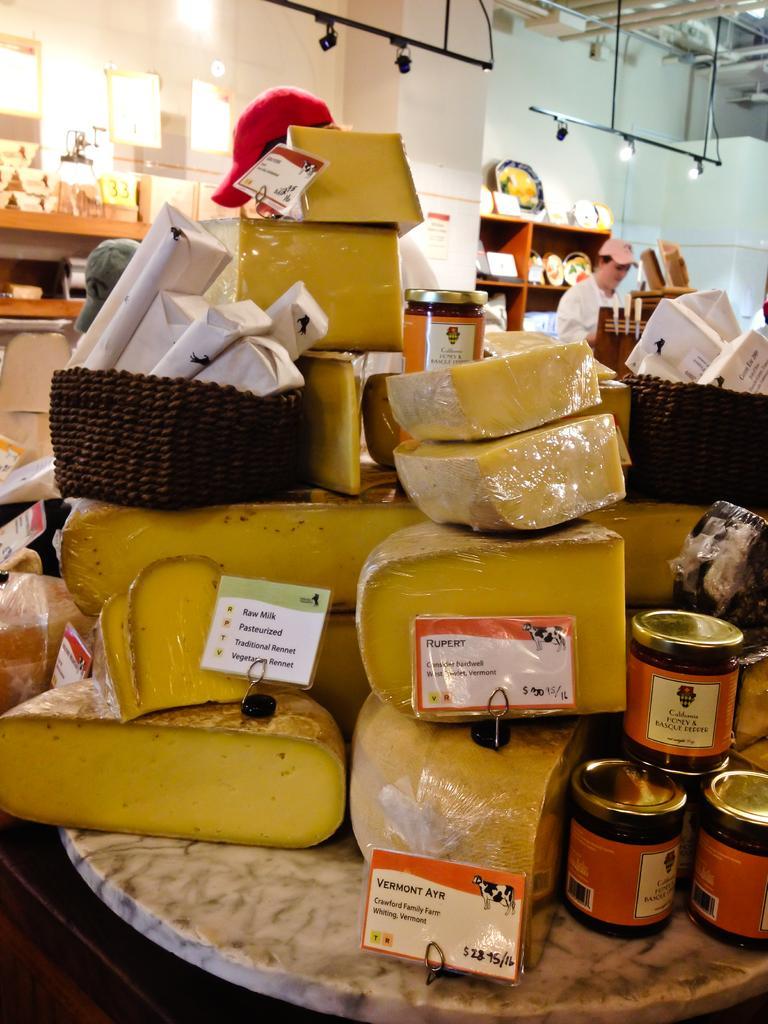Please provide a concise description of this image. As we can see in the image there are boxes, bottles, shelves, plates, wall and a man standing over here. 